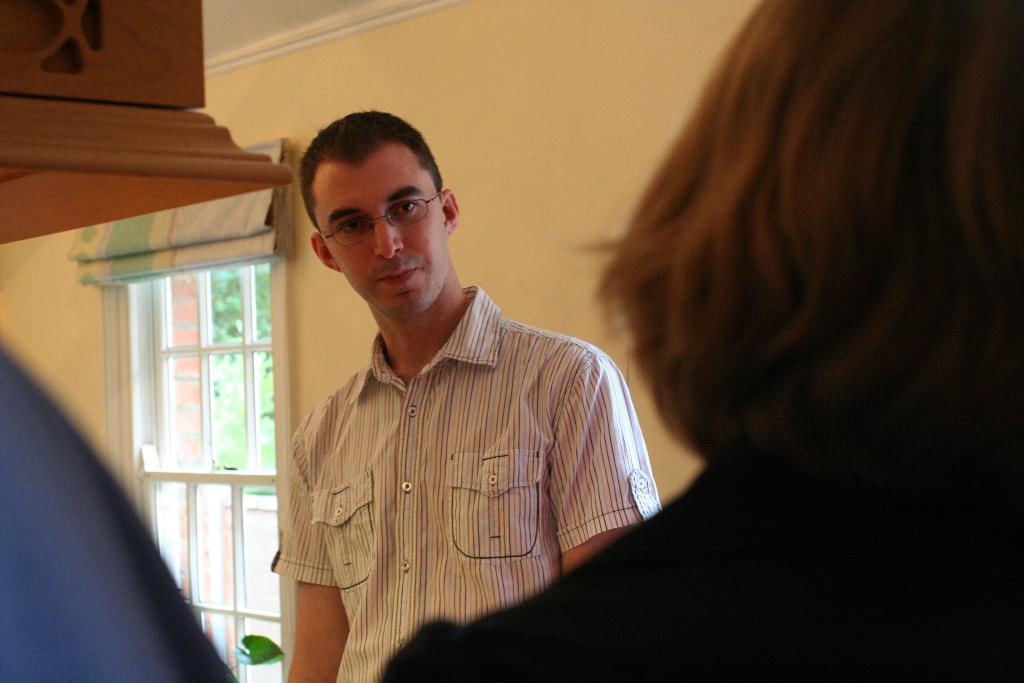Could you give a brief overview of what you see in this image? In the picture we can see a man standing inside the house in front of a woman and in the background, we can see a wall with a window and some curtain on the top of it. 